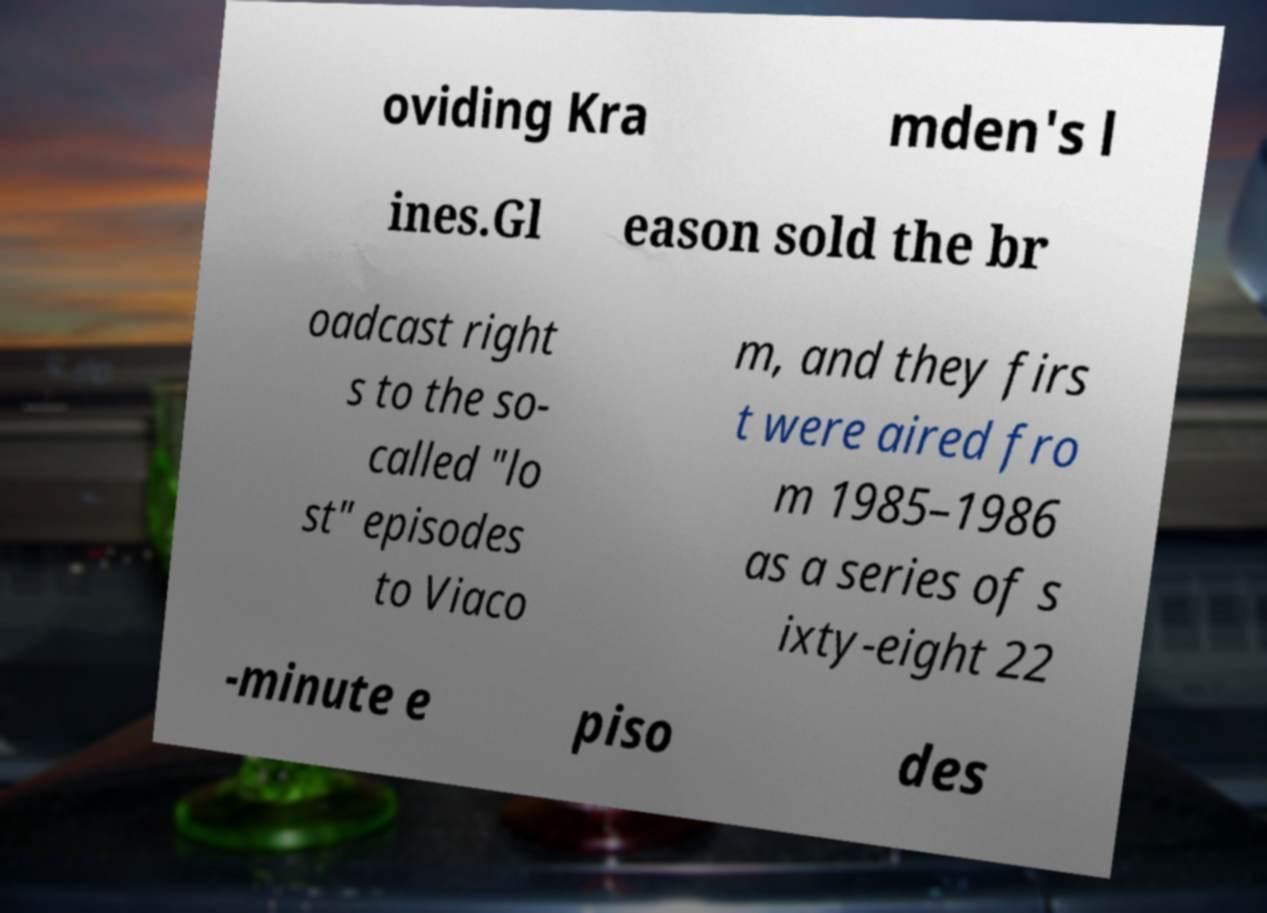Could you extract and type out the text from this image? oviding Kra mden's l ines.Gl eason sold the br oadcast right s to the so- called "lo st" episodes to Viaco m, and they firs t were aired fro m 1985–1986 as a series of s ixty-eight 22 -minute e piso des 